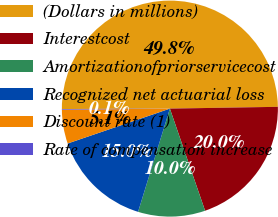Convert chart to OTSL. <chart><loc_0><loc_0><loc_500><loc_500><pie_chart><fcel>(Dollars in millions)<fcel>Interestcost<fcel>Amortizationofpriorservicecost<fcel>Recognized net actuarial loss<fcel>Discount rate (1)<fcel>Rate of compensation increase<nl><fcel>49.8%<fcel>19.98%<fcel>10.04%<fcel>15.01%<fcel>5.07%<fcel>0.1%<nl></chart> 